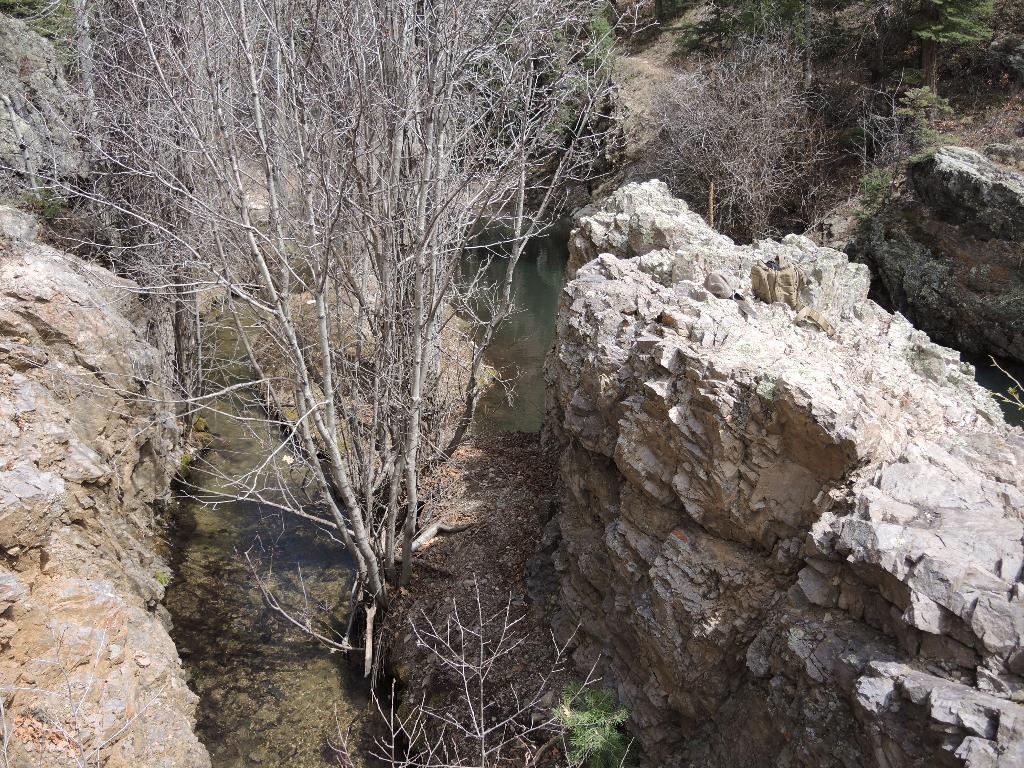Can you describe this image briefly? In this image we can see rocks and some dried plants. 